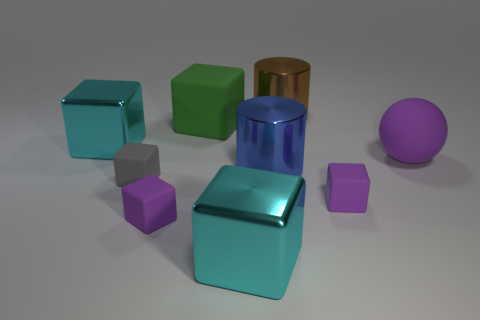Subtract 2 blocks. How many blocks are left? 4 Subtract all purple blocks. How many blocks are left? 4 Subtract all big cyan shiny blocks. How many blocks are left? 4 Subtract all green cubes. Subtract all purple cylinders. How many cubes are left? 5 Add 1 rubber things. How many objects exist? 10 Subtract all balls. How many objects are left? 8 Add 5 big cyan things. How many big cyan things exist? 7 Subtract 1 brown cylinders. How many objects are left? 8 Subtract all tiny purple blocks. Subtract all large spheres. How many objects are left? 6 Add 8 large cyan shiny cubes. How many large cyan shiny cubes are left? 10 